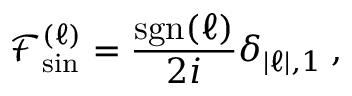Convert formula to latex. <formula><loc_0><loc_0><loc_500><loc_500>\mathcal { F } _ { \sin } ^ { ( \ell ) } = \frac { s g n ( \ell ) } { 2 i } \delta _ { | \ell | , 1 } \, ,</formula> 